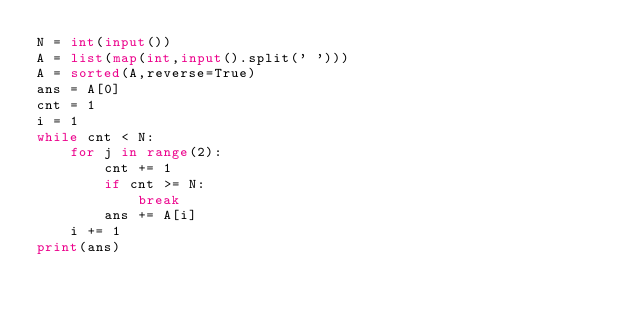<code> <loc_0><loc_0><loc_500><loc_500><_Python_>N = int(input())
A = list(map(int,input().split(' ')))
A = sorted(A,reverse=True)
ans = A[0]
cnt = 1
i = 1
while cnt < N:
    for j in range(2):
        cnt += 1
        if cnt >= N:
            break
        ans += A[i]
    i += 1
print(ans)</code> 